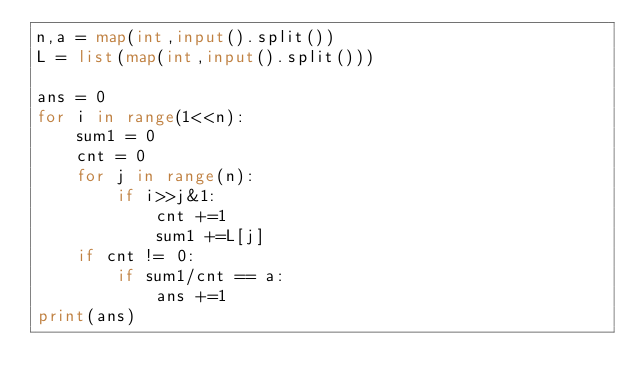<code> <loc_0><loc_0><loc_500><loc_500><_Python_>n,a = map(int,input().split())
L = list(map(int,input().split()))

ans = 0
for i in range(1<<n):
    sum1 = 0
    cnt = 0
    for j in range(n):
        if i>>j&1:
            cnt +=1
            sum1 +=L[j]
    if cnt != 0:
        if sum1/cnt == a:
            ans +=1
print(ans)</code> 